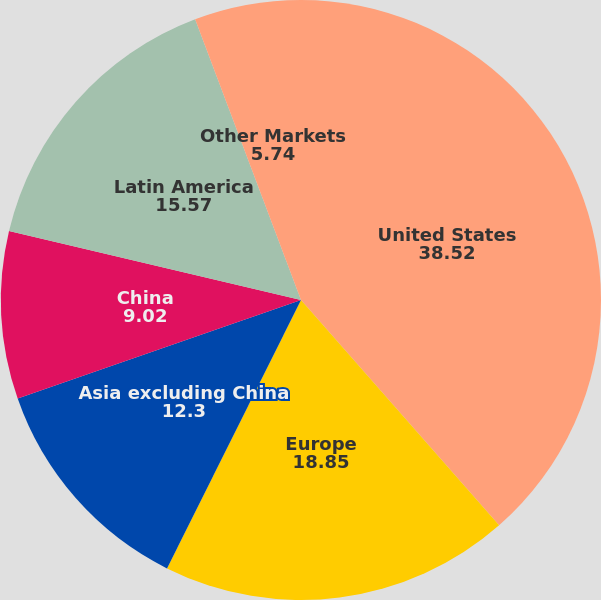<chart> <loc_0><loc_0><loc_500><loc_500><pie_chart><fcel>United States<fcel>Europe<fcel>Asia excluding China<fcel>China<fcel>Latin America<fcel>Other Markets<nl><fcel>38.52%<fcel>18.85%<fcel>12.3%<fcel>9.02%<fcel>15.57%<fcel>5.74%<nl></chart> 